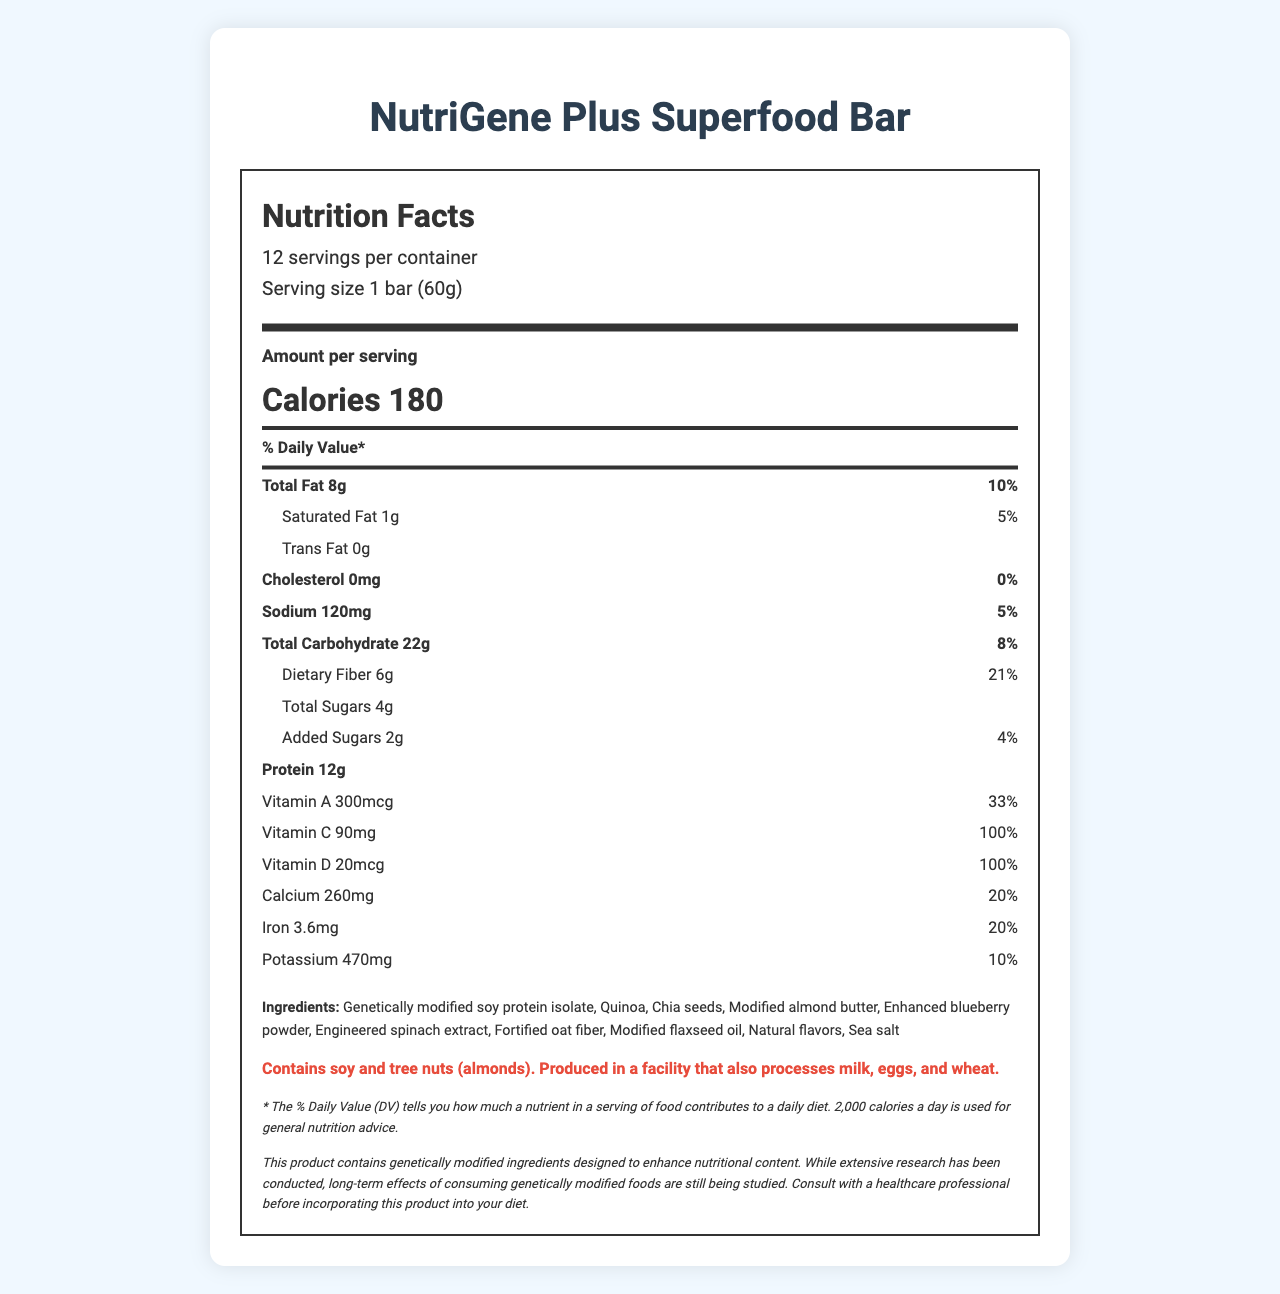what is the serving size of the NutriGene Plus Superfood Bar? The serving size is clearly listed in the document under the serving information section as "1 bar (60g)".
Answer: 1 bar (60g) how many servings are in one container of NutriGene Plus Superfood Bar? The document specifies "12 servings per container" in the serving information section.
Answer: 12 what is the total amount of dietary fiber per serving? The amount of dietary fiber is listed directly under the total carbohydrate section as "Dietary Fiber 6g."
Answer: 6g what are the total calories per serving of NutriGene Plus Superfood Bar? The calories per serving are prominently displayed in bold as "Calories 180".
Answer: 180 calories what are the main ingredients in the NutriGene Plus Superfood Bar? The ingredients are listed towards the end of the document in the "Ingredients" section.
Answer: Genetically modified soy protein isolate, Quinoa, Chia seeds, Modified almond butter, Enhanced blueberry powder, Engineered spinach extract, Fortified oat fiber, Modified flaxseed oil, Natural flavors, Sea salt How much protein does each bar contain? The document states the protein content directly under the nutrient rows as "Protein 12g."
Answer: 12g what is the daily value percentage of Vitamin C in each bar? A. 50% B. 100% C. 33% D. 20% The document states the daily value percentage of Vitamin C as "Vitamin C 90mg 100%" in the nutrient rows.
Answer: B. 100% what amount of added sugars are in each serving? A. 1g B. 2g C. 3g D. 4g The amount of added sugars is directly listed as "Added Sugars 2g" in the sub-nutrient section under total carbohydrate.
Answer: B. 2g Does the NutriGene Plus Superfood Bar contain any allergenic ingredients? The allergen information states "Contains soy and tree nuts (almonds). Produced in a facility that also processes milk, eggs, and wheat."
Answer: Yes What is the main nutritional enhancement feature of this genetically modified superfood? The scientific note mentions, "genetically modified ingredients designed to enhance nutritional content."
Answer: Enhanced nutritional content through genetically modified ingredients what is the total fat content per serving and its daily value percentage? The document lists total fat content as "Total Fat 8g" and daily value percentage as "10%" in the corresponding row.
Answer: 8g, 10% what is the primary concern related to the long-term consumption of the product as mentioned in the scientific note? A. Nutrient deficiency B. Toxicity C. Long-term effects of genetically modified foods The scientific note mentions, "long-term effects of consuming genetically modified foods are still being studied."
Answer: C. Long-term effects of genetically modified foods what are the specific quantities and daily values of selenium and zinc in the product? Selenium and Zinc amounts along with their daily values are listed under their respective rows.
Answer: Selenium: 11mcg, 20%; Zinc: 2.2mg, 20% Summarize the main idea of the NutriGene Plus Superfood Bar nutrition facts document. The document is a detailed nutrition facts label designed to inform consumers about the nutritional content, ingredients, and potential allergens in the NutriGene Plus Superfood Bar. It also includes a disclaimer and a scientific note about the use of genetically modified ingredients to enhance nutritional content.
Answer: The NutriGene Plus Superfood Bar is a genetically modified superfood designed to provide enhanced nutrition, and each serving contains various vitamins, minerals, and other nutrients. The label provides detailed information about the nutrient content, serving size, ingredients, and potential allergens. There is a note regarding the scientific uncertainty about the long-term effects of GMOs. how does the NutriGene Plus Superfood Bar ensure a high vitamin and mineral content? The scientific note at the end of the document mentions that the product uses genetically modified ingredients to enhance nutritional content.
Answer: By using genetically modified ingredients specifically designed to enhance nutritional content does the product contain any animal-derived ingredients? The document does not specify whether the listed ingredients are derived from animals or not, so this information cannot be determined from the document.
Answer: Not enough information which vitamins and minerals are present at 100% of the daily value in each serving? These vitamins and minerals are listed as having 100% daily value next to their respective amounts in the nutrient rows.
Answer: Vitamin C, Vitamin D, Vitamin E, Vitamin K, Thiamin, Riboflavin, Niacin, Vitamin B6, Folate, Vitamin B12, Biotin, Pantothenic Acid what is the main warning provided in the scientific note on the label? The scientific note provides a warning about the ongoing study of long-term effects of genetically modified foods and suggests consulting a healthcare professional before consumption.
Answer: Long-term effects of consuming genetically modified foods are still being studied. Consult with a healthcare professional before incorporating this product into your diet. Can the nutritional information in this label be used for someone's entire daily dietary intake assessment? The disclaimer states that the % Daily Value is based on a 2,000 calorie diet, implying it's just a general guideline and may not be comprehensive for all dietary assessments.
Answer: No 